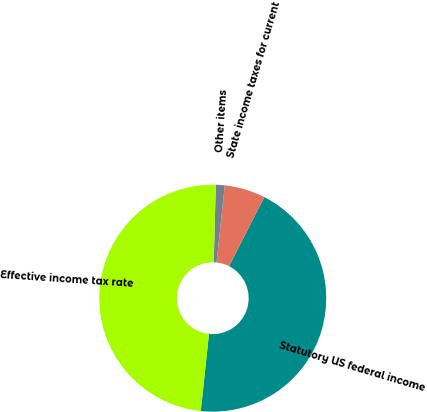<chart> <loc_0><loc_0><loc_500><loc_500><pie_chart><fcel>Statutory US federal income<fcel>State income taxes for current<fcel>Other items<fcel>Effective income tax rate<nl><fcel>44.18%<fcel>5.82%<fcel>1.26%<fcel>48.74%<nl></chart> 